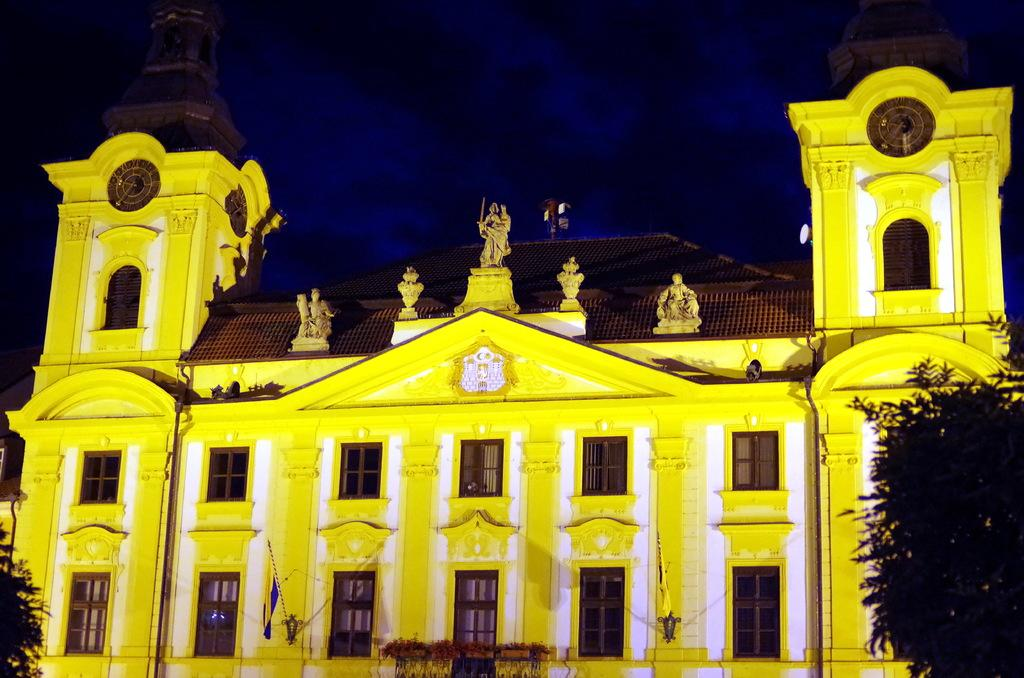What is the main structure in the center of the image? There is a building in the center of the image. What else can be seen in the center of the image besides the building? There are flags in the center of the image. What type of vegetation is present on both sides of the image? There are trees on both the right and left sides of the image. What is visible in the background of the image? The sky is visible in the background of the image. What type of fowl can be seen perched on the building in the image? There are no fowl present on the building in the image. How many spiders are visible on the trees in the image? There are no spiders visible on the trees in the image. 